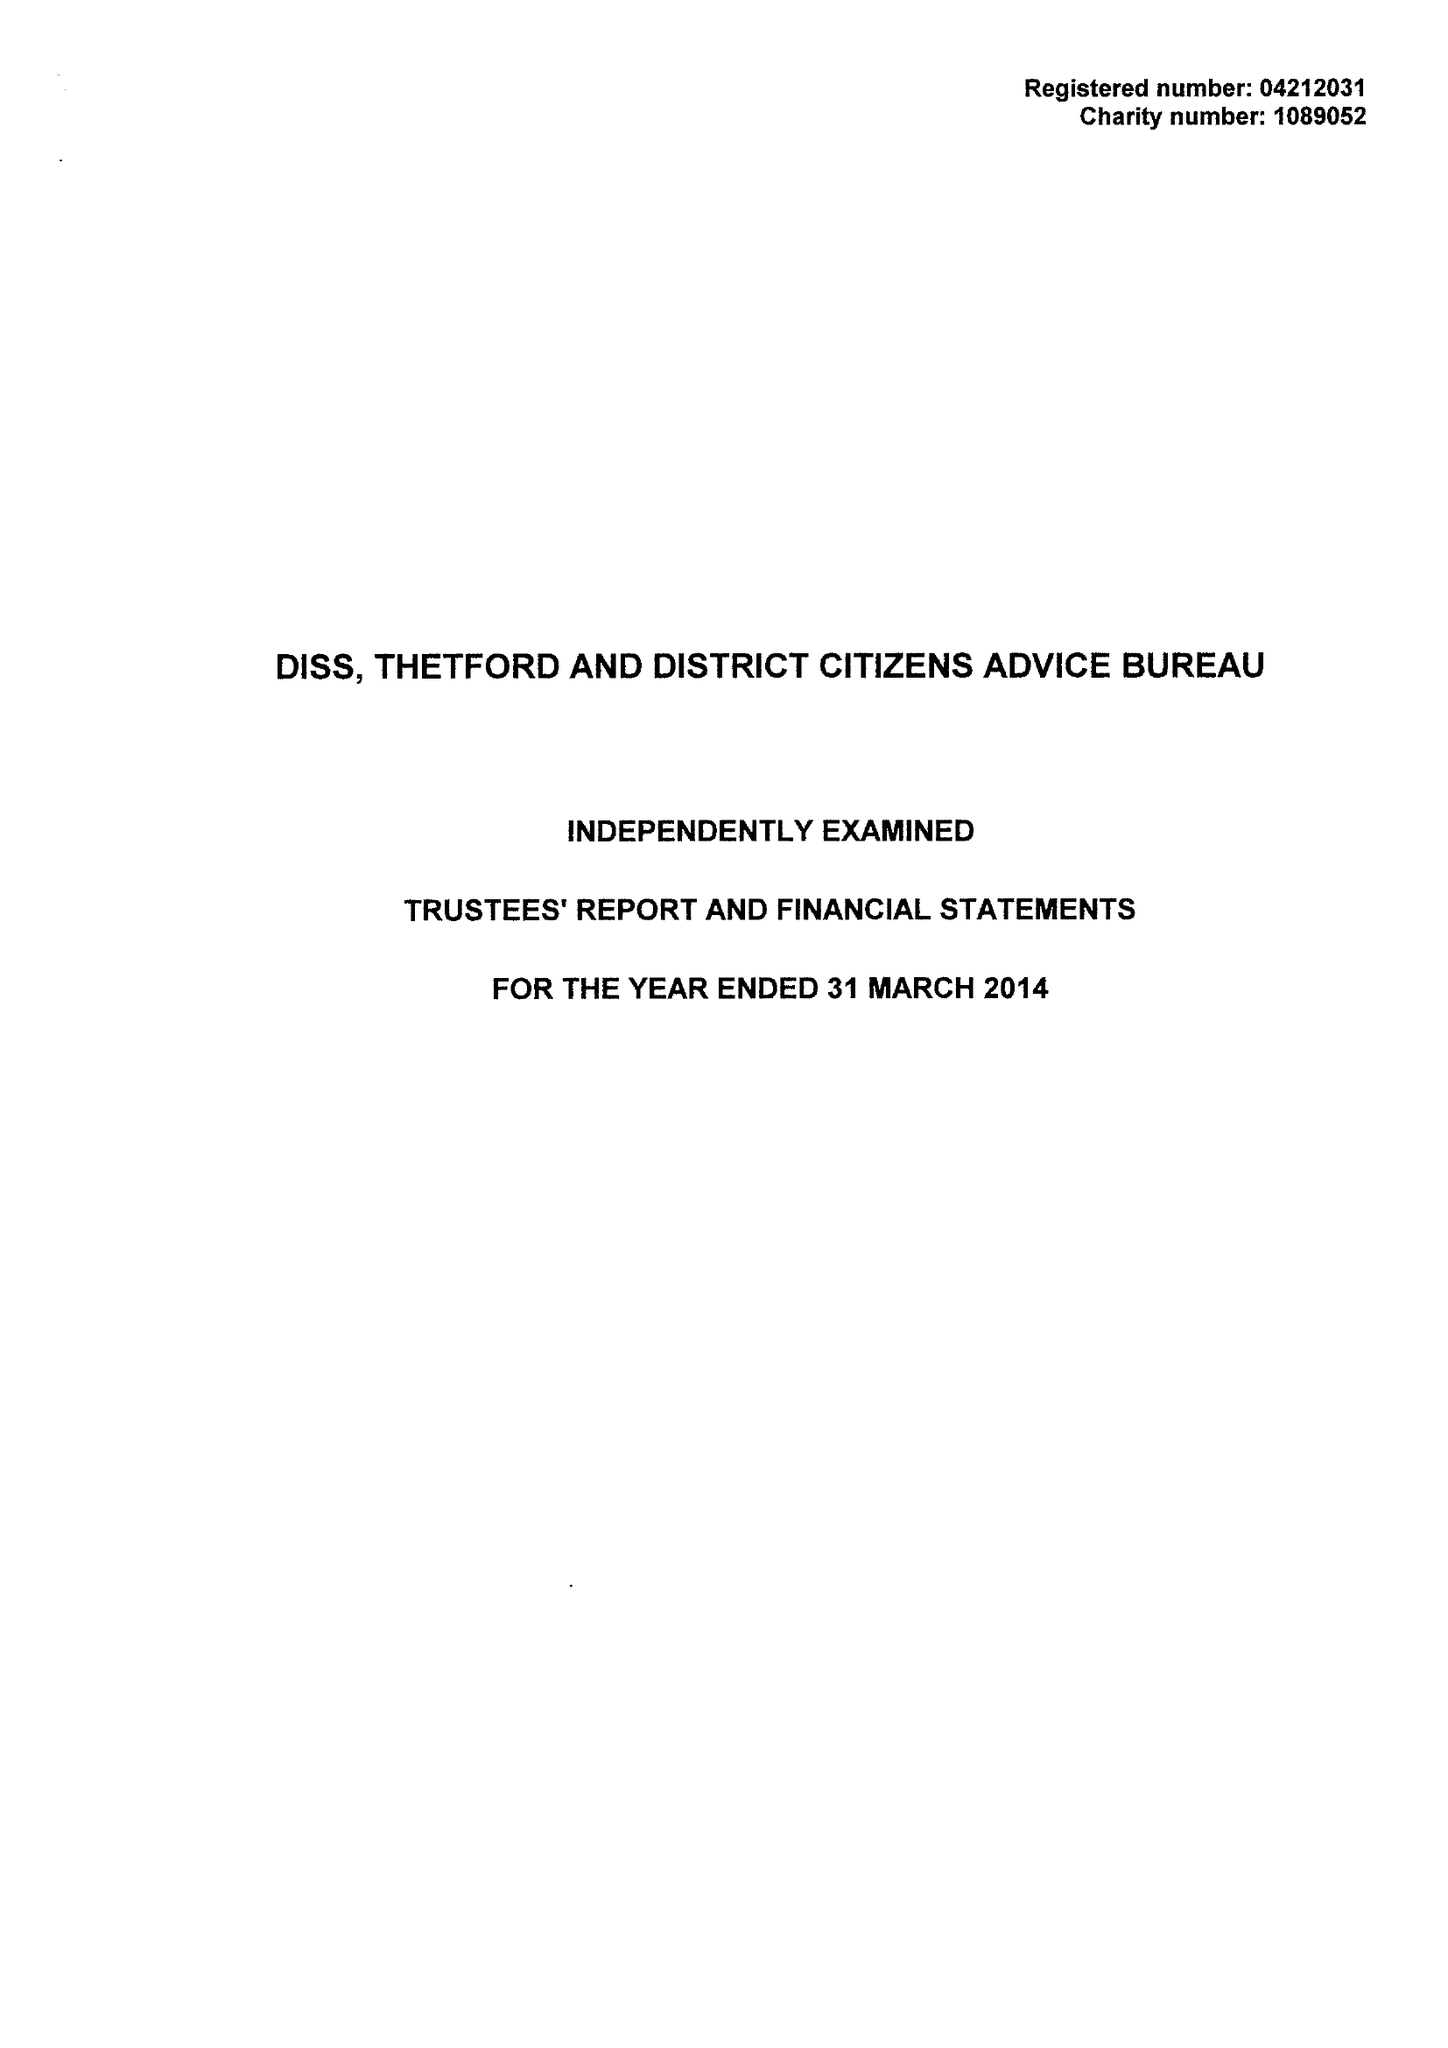What is the value for the address__post_town?
Answer the question using a single word or phrase. DISS 